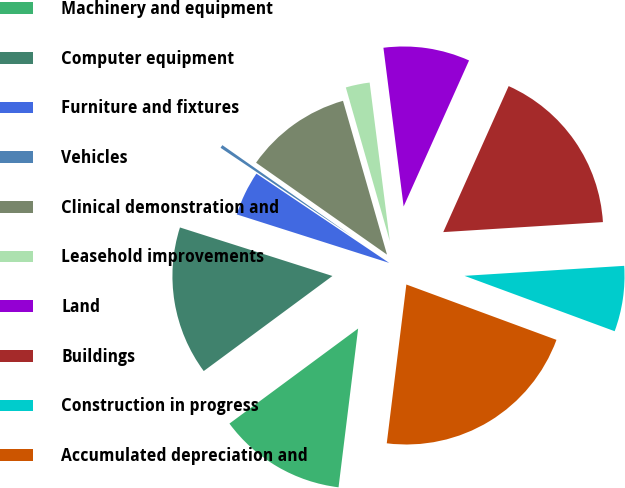Convert chart. <chart><loc_0><loc_0><loc_500><loc_500><pie_chart><fcel>Machinery and equipment<fcel>Computer equipment<fcel>Furniture and fixtures<fcel>Vehicles<fcel>Clinical demonstration and<fcel>Leasehold improvements<fcel>Land<fcel>Buildings<fcel>Construction in progress<fcel>Accumulated depreciation and<nl><fcel>12.92%<fcel>15.03%<fcel>4.52%<fcel>0.32%<fcel>10.82%<fcel>2.42%<fcel>8.72%<fcel>17.3%<fcel>6.62%<fcel>21.33%<nl></chart> 